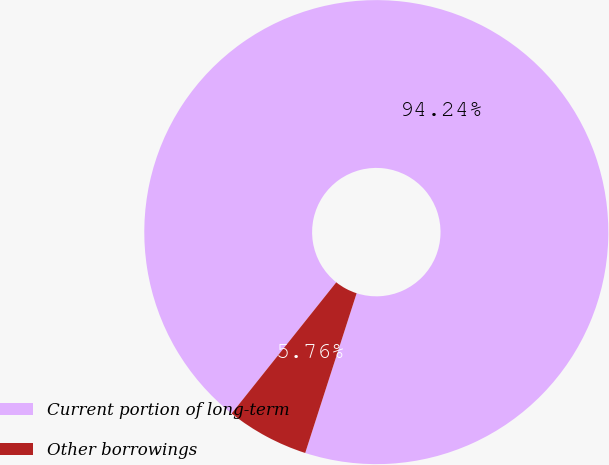Convert chart. <chart><loc_0><loc_0><loc_500><loc_500><pie_chart><fcel>Current portion of long-term<fcel>Other borrowings<nl><fcel>94.24%<fcel>5.76%<nl></chart> 